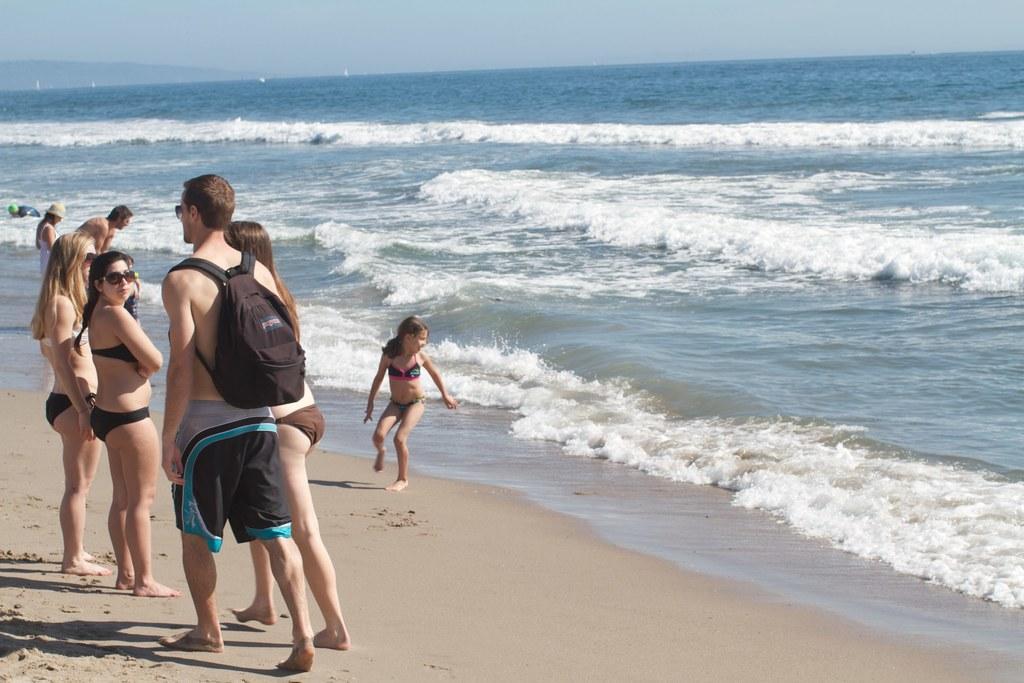Can you describe this image briefly? There are few persons standing on sand in the left corner and there are water in front of them. 